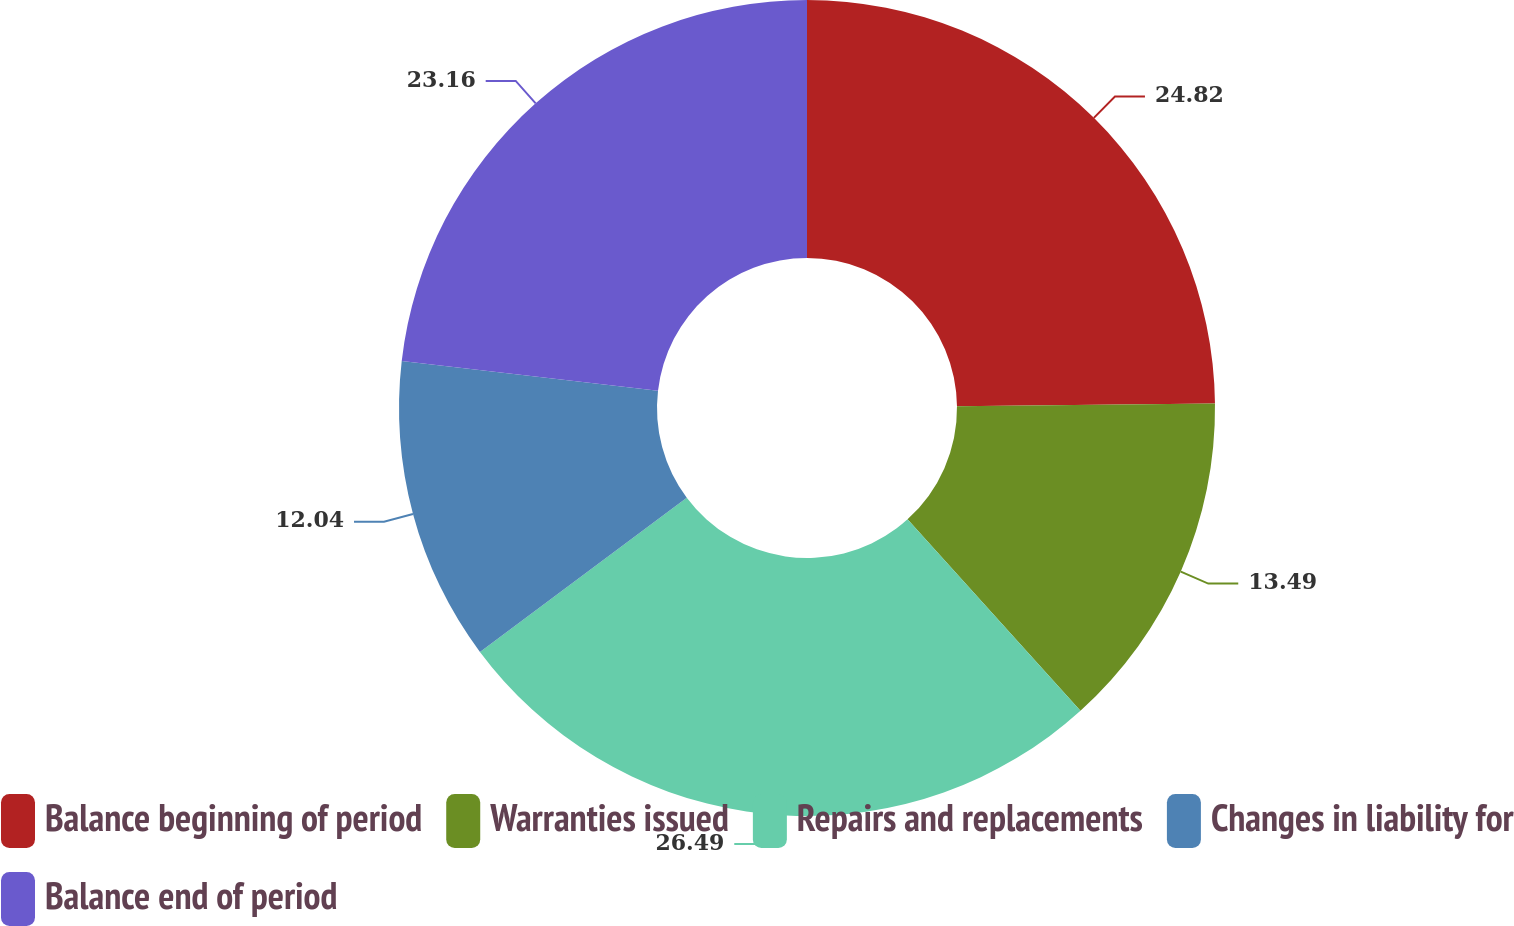Convert chart. <chart><loc_0><loc_0><loc_500><loc_500><pie_chart><fcel>Balance beginning of period<fcel>Warranties issued<fcel>Repairs and replacements<fcel>Changes in liability for<fcel>Balance end of period<nl><fcel>24.82%<fcel>13.49%<fcel>26.49%<fcel>12.04%<fcel>23.16%<nl></chart> 